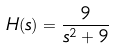Convert formula to latex. <formula><loc_0><loc_0><loc_500><loc_500>H ( s ) = \frac { 9 } { s ^ { 2 } + 9 }</formula> 